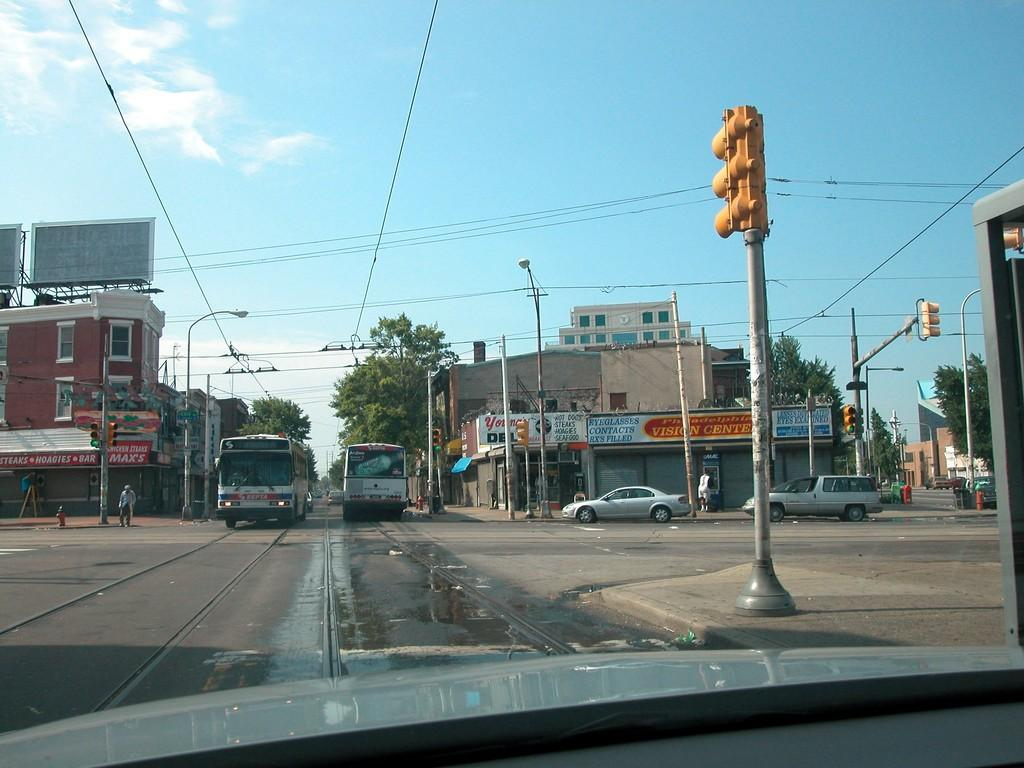What can be seen on the road in the image? There are vehicles on the road in the image. What else is visible in the image besides the vehicles? Buildings, trees, traffic lights, street lights, and wires are visible in the image. Can you describe the person in the image? There is a person near a traffic light in the image. What is visible at the top of the image? The sky is visible at the top of the image. What type of noise can be heard coming from the swing in the image? There is no swing present in the image, so no such noise can be heard. What type of connection is visible between the buildings in the image? There is no specific connection between the buildings mentioned in the provided facts, so it cannot be determined from the image. 